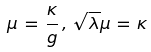<formula> <loc_0><loc_0><loc_500><loc_500>\mu \, = \, \frac { \kappa } { g } \, , \, \sqrt { \lambda } \mu \, = \, \kappa</formula> 